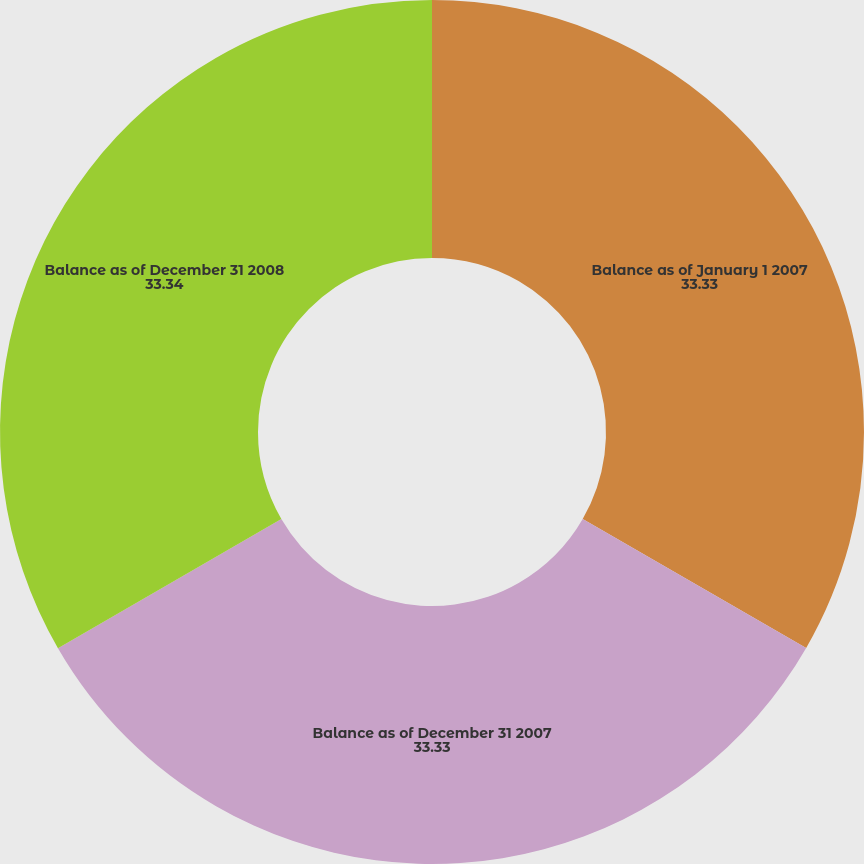<chart> <loc_0><loc_0><loc_500><loc_500><pie_chart><fcel>Balance as of January 1 2007<fcel>Balance as of December 31 2007<fcel>Balance as of December 31 2008<nl><fcel>33.33%<fcel>33.33%<fcel>33.34%<nl></chart> 